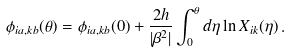Convert formula to latex. <formula><loc_0><loc_0><loc_500><loc_500>\phi _ { i a , k b } ( \theta ) = \phi _ { i a , k b } ( 0 ) + \frac { 2 h } { | \beta ^ { 2 } | } \int ^ { \theta } _ { 0 } d \eta \ln X _ { i k } ( \eta ) \, .</formula> 